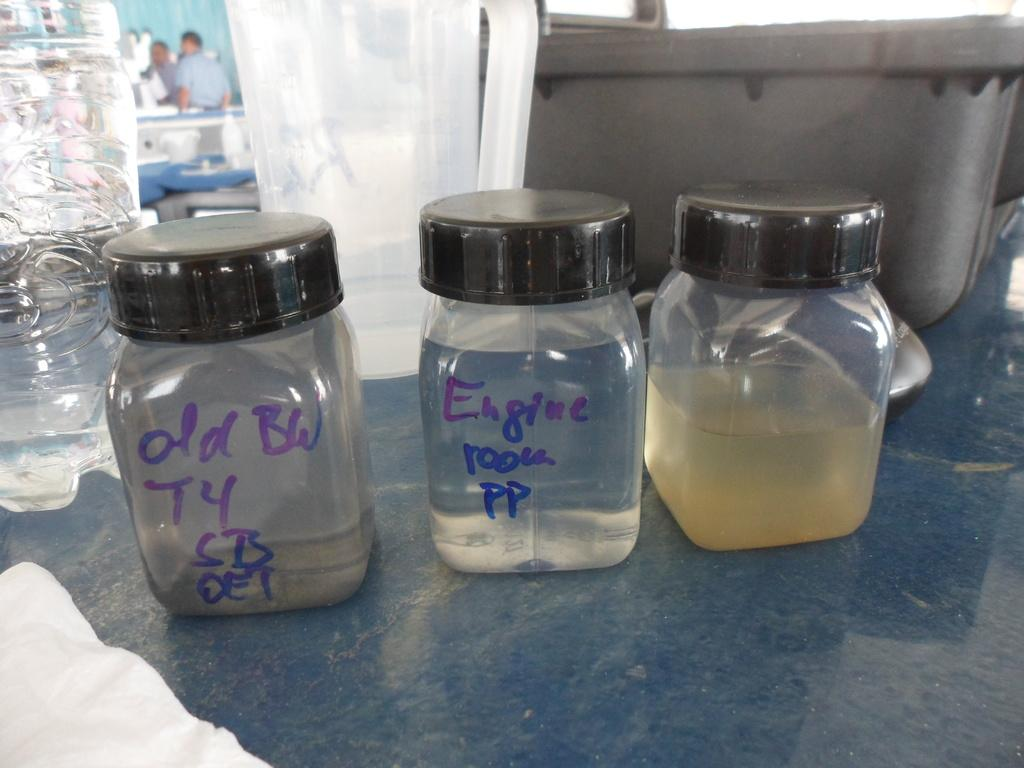<image>
Describe the image concisely. Glass jars contain some sort of liquid and are marked as Old BW T4 and Engine Room PP. 